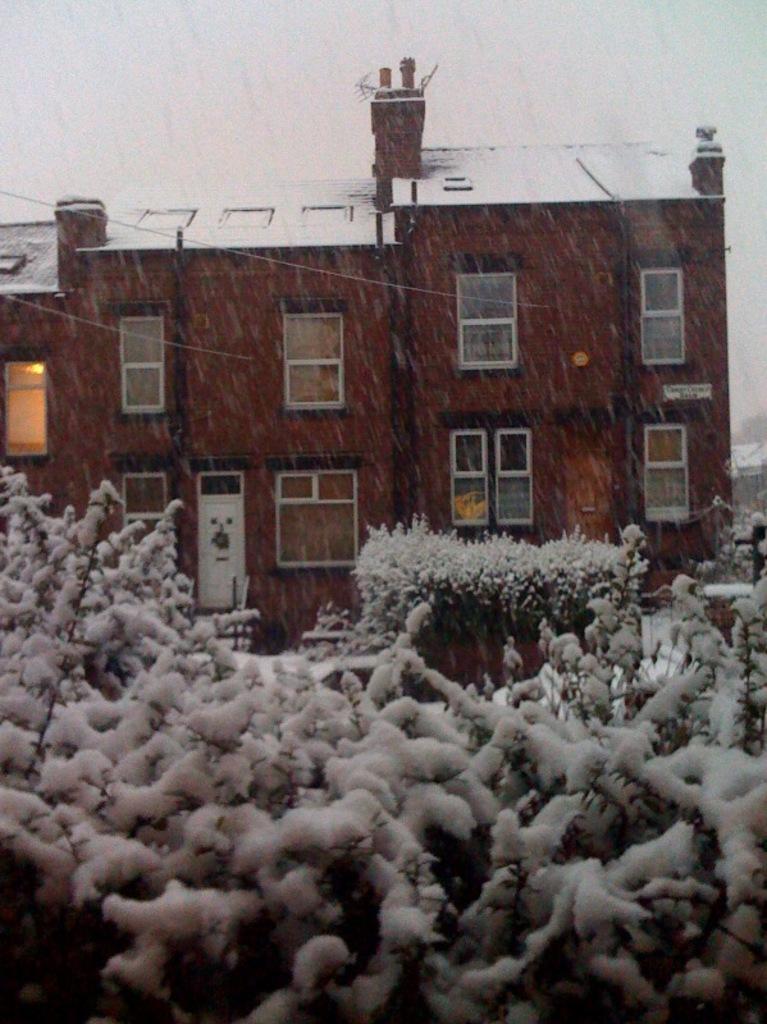Can you describe this image briefly? This image is taken outdoors. At the top of the image there is the sky and there is a snowfall. In the middle of the image there is a building with walls, windows, a door and a roof. At the bottom of the image there are a few plants covered with snow. 